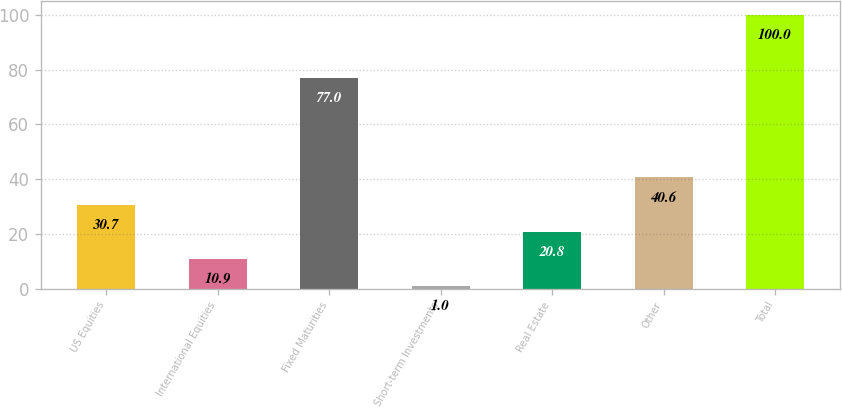Convert chart to OTSL. <chart><loc_0><loc_0><loc_500><loc_500><bar_chart><fcel>US Equities<fcel>International Equities<fcel>Fixed Maturities<fcel>Short-term Investments<fcel>Real Estate<fcel>Other<fcel>Total<nl><fcel>30.7<fcel>10.9<fcel>77<fcel>1<fcel>20.8<fcel>40.6<fcel>100<nl></chart> 